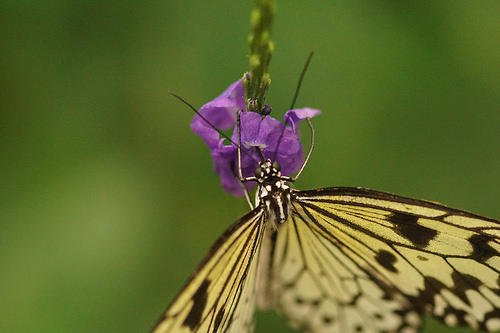<image>
Can you confirm if the flower is on the butterfly? No. The flower is not positioned on the butterfly. They may be near each other, but the flower is not supported by or resting on top of the butterfly. Is the butterfly under the flower? Yes. The butterfly is positioned underneath the flower, with the flower above it in the vertical space. 